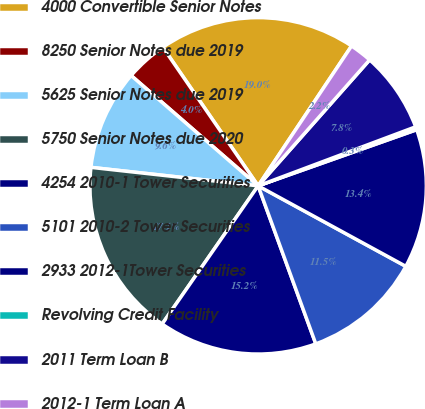Convert chart. <chart><loc_0><loc_0><loc_500><loc_500><pie_chart><fcel>4000 Convertible Senior Notes<fcel>8250 Senior Notes due 2019<fcel>5625 Senior Notes due 2019<fcel>5750 Senior Notes due 2020<fcel>4254 2010-1 Tower Securities<fcel>5101 2010-2 Tower Securities<fcel>2933 2012-1Tower Securities<fcel>Revolving Credit Facility<fcel>2011 Term Loan B<fcel>2012-1 Term Loan A<nl><fcel>18.96%<fcel>4.03%<fcel>9.63%<fcel>17.09%<fcel>15.23%<fcel>11.49%<fcel>13.36%<fcel>0.29%<fcel>7.76%<fcel>2.16%<nl></chart> 